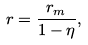Convert formula to latex. <formula><loc_0><loc_0><loc_500><loc_500>r = \frac { r _ { m } } { 1 - \eta } ,</formula> 